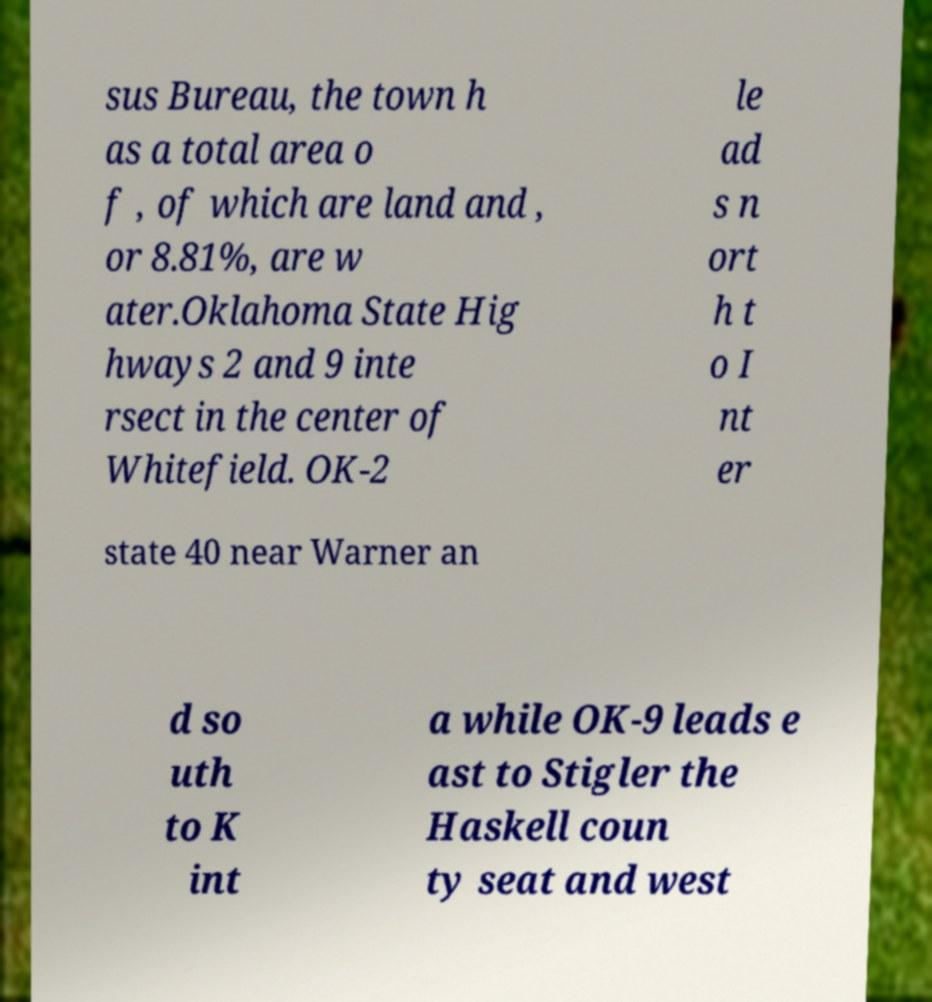For documentation purposes, I need the text within this image transcribed. Could you provide that? sus Bureau, the town h as a total area o f , of which are land and , or 8.81%, are w ater.Oklahoma State Hig hways 2 and 9 inte rsect in the center of Whitefield. OK-2 le ad s n ort h t o I nt er state 40 near Warner an d so uth to K int a while OK-9 leads e ast to Stigler the Haskell coun ty seat and west 